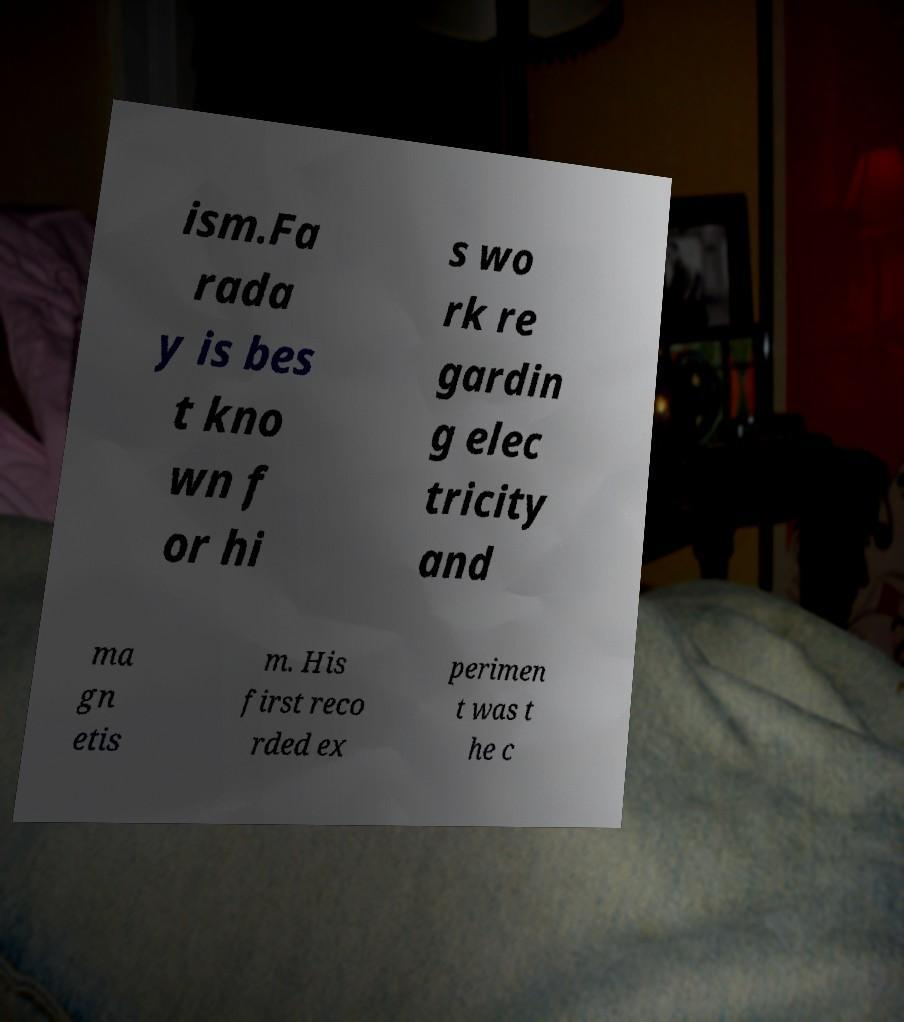Could you assist in decoding the text presented in this image and type it out clearly? ism.Fa rada y is bes t kno wn f or hi s wo rk re gardin g elec tricity and ma gn etis m. His first reco rded ex perimen t was t he c 